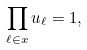Convert formula to latex. <formula><loc_0><loc_0><loc_500><loc_500>\prod _ { \ell \in x } u _ { \ell } = 1 ,</formula> 